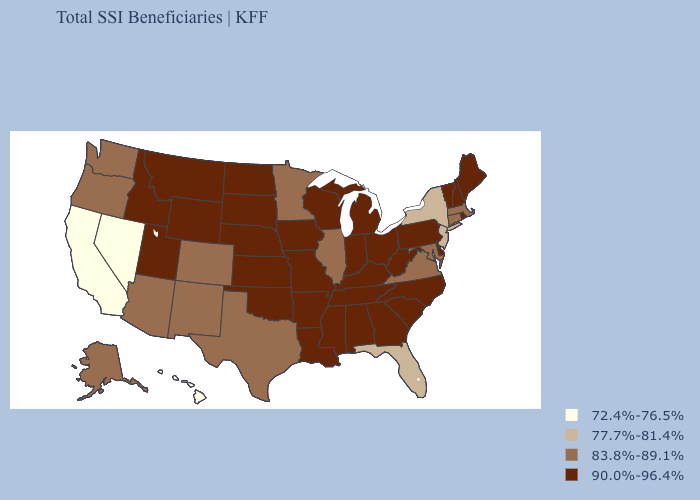Does Florida have the highest value in the South?
Concise answer only. No. What is the highest value in the USA?
Short answer required. 90.0%-96.4%. Does Georgia have the lowest value in the South?
Concise answer only. No. Among the states that border North Carolina , does Virginia have the lowest value?
Quick response, please. Yes. Which states have the lowest value in the USA?
Short answer required. California, Hawaii, Nevada. What is the value of New Jersey?
Answer briefly. 77.7%-81.4%. What is the highest value in states that border Texas?
Short answer required. 90.0%-96.4%. What is the lowest value in the USA?
Write a very short answer. 72.4%-76.5%. Name the states that have a value in the range 72.4%-76.5%?
Keep it brief. California, Hawaii, Nevada. Does Pennsylvania have the lowest value in the Northeast?
Give a very brief answer. No. Among the states that border Tennessee , which have the highest value?
Write a very short answer. Alabama, Arkansas, Georgia, Kentucky, Mississippi, Missouri, North Carolina. What is the highest value in the USA?
Quick response, please. 90.0%-96.4%. Which states have the lowest value in the South?
Give a very brief answer. Florida. Name the states that have a value in the range 72.4%-76.5%?
Concise answer only. California, Hawaii, Nevada. What is the value of West Virginia?
Write a very short answer. 90.0%-96.4%. 